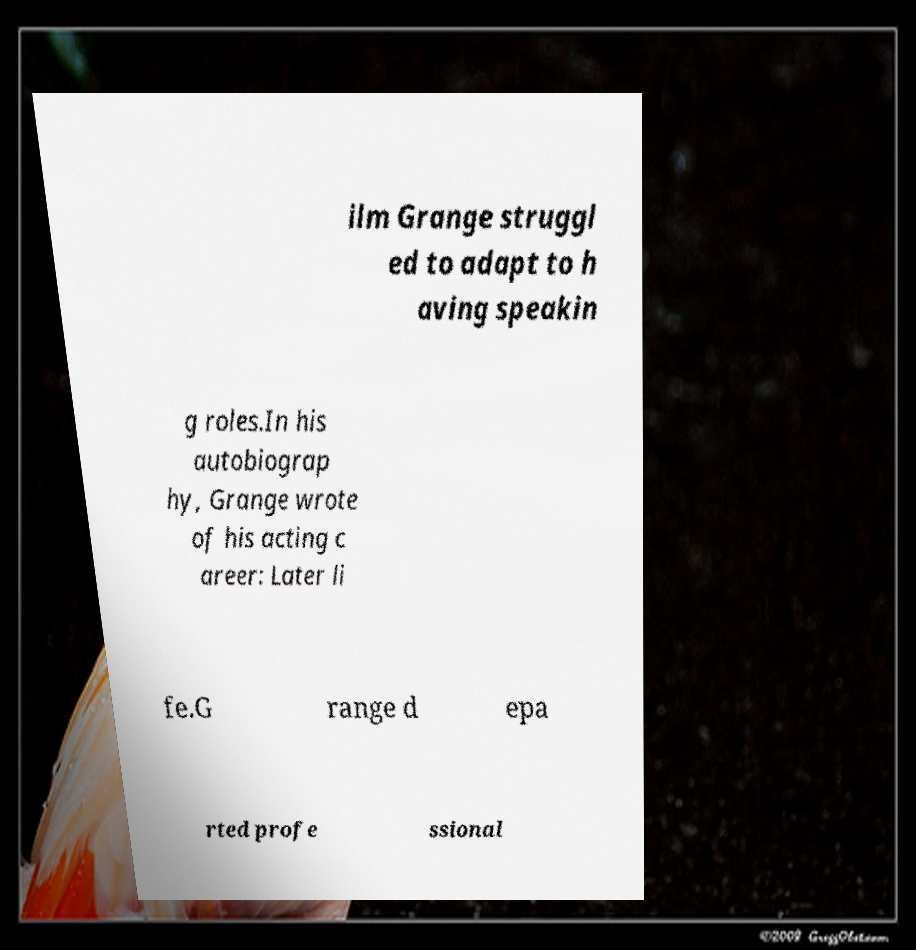Can you read and provide the text displayed in the image?This photo seems to have some interesting text. Can you extract and type it out for me? ilm Grange struggl ed to adapt to h aving speakin g roles.In his autobiograp hy, Grange wrote of his acting c areer: Later li fe.G range d epa rted profe ssional 